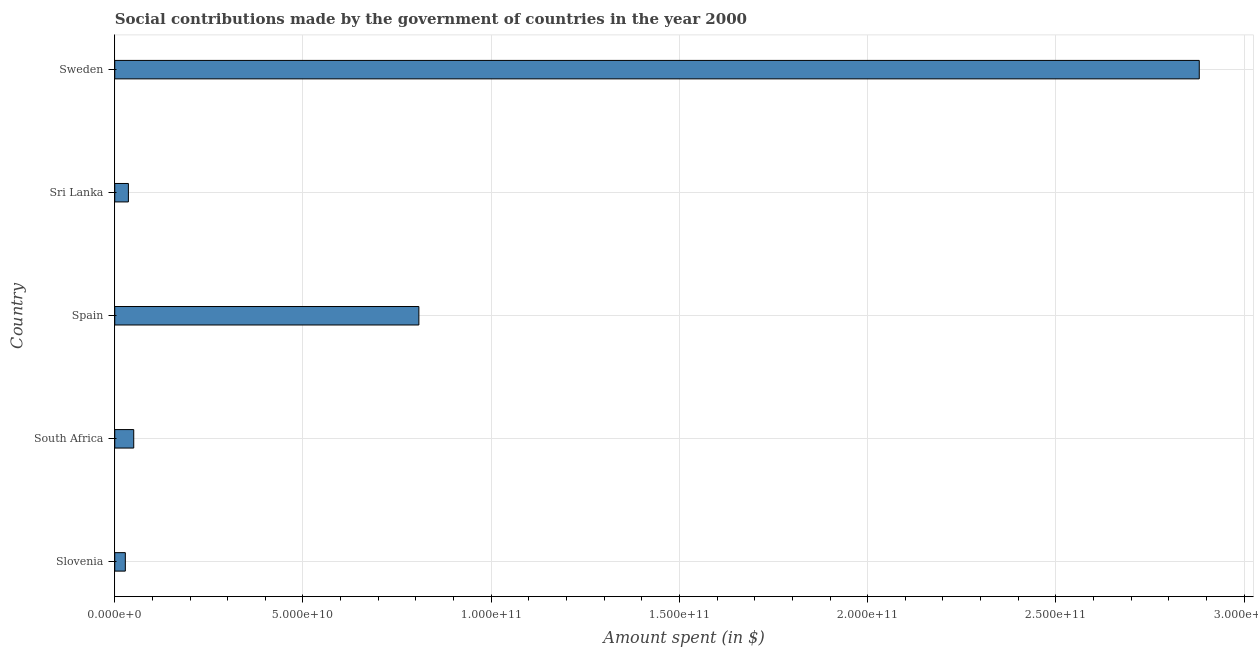Does the graph contain grids?
Offer a very short reply. Yes. What is the title of the graph?
Keep it short and to the point. Social contributions made by the government of countries in the year 2000. What is the label or title of the X-axis?
Offer a terse response. Amount spent (in $). What is the amount spent in making social contributions in Sweden?
Your answer should be very brief. 2.88e+11. Across all countries, what is the maximum amount spent in making social contributions?
Ensure brevity in your answer.  2.88e+11. Across all countries, what is the minimum amount spent in making social contributions?
Make the answer very short. 2.81e+09. In which country was the amount spent in making social contributions maximum?
Ensure brevity in your answer.  Sweden. In which country was the amount spent in making social contributions minimum?
Your response must be concise. Slovenia. What is the sum of the amount spent in making social contributions?
Your response must be concise. 3.80e+11. What is the difference between the amount spent in making social contributions in Spain and Sweden?
Provide a succinct answer. -2.07e+11. What is the average amount spent in making social contributions per country?
Give a very brief answer. 7.61e+1. What is the median amount spent in making social contributions?
Provide a short and direct response. 5.04e+09. What is the ratio of the amount spent in making social contributions in South Africa to that in Spain?
Ensure brevity in your answer.  0.06. Is the amount spent in making social contributions in Slovenia less than that in Sri Lanka?
Your answer should be compact. Yes. Is the difference between the amount spent in making social contributions in Slovenia and Spain greater than the difference between any two countries?
Your response must be concise. No. What is the difference between the highest and the second highest amount spent in making social contributions?
Offer a terse response. 2.07e+11. What is the difference between the highest and the lowest amount spent in making social contributions?
Provide a short and direct response. 2.85e+11. How many bars are there?
Offer a terse response. 5. Are all the bars in the graph horizontal?
Ensure brevity in your answer.  Yes. How many countries are there in the graph?
Offer a terse response. 5. Are the values on the major ticks of X-axis written in scientific E-notation?
Keep it short and to the point. Yes. What is the Amount spent (in $) of Slovenia?
Ensure brevity in your answer.  2.81e+09. What is the Amount spent (in $) in South Africa?
Provide a short and direct response. 5.04e+09. What is the Amount spent (in $) in Spain?
Your response must be concise. 8.08e+1. What is the Amount spent (in $) in Sri Lanka?
Offer a very short reply. 3.62e+09. What is the Amount spent (in $) of Sweden?
Make the answer very short. 2.88e+11. What is the difference between the Amount spent (in $) in Slovenia and South Africa?
Your response must be concise. -2.23e+09. What is the difference between the Amount spent (in $) in Slovenia and Spain?
Your answer should be very brief. -7.80e+1. What is the difference between the Amount spent (in $) in Slovenia and Sri Lanka?
Your answer should be very brief. -8.11e+08. What is the difference between the Amount spent (in $) in Slovenia and Sweden?
Keep it short and to the point. -2.85e+11. What is the difference between the Amount spent (in $) in South Africa and Spain?
Ensure brevity in your answer.  -7.57e+1. What is the difference between the Amount spent (in $) in South Africa and Sri Lanka?
Make the answer very short. 1.42e+09. What is the difference between the Amount spent (in $) in South Africa and Sweden?
Your answer should be compact. -2.83e+11. What is the difference between the Amount spent (in $) in Spain and Sri Lanka?
Your response must be concise. 7.72e+1. What is the difference between the Amount spent (in $) in Spain and Sweden?
Provide a short and direct response. -2.07e+11. What is the difference between the Amount spent (in $) in Sri Lanka and Sweden?
Provide a succinct answer. -2.84e+11. What is the ratio of the Amount spent (in $) in Slovenia to that in South Africa?
Your response must be concise. 0.56. What is the ratio of the Amount spent (in $) in Slovenia to that in Spain?
Make the answer very short. 0.04. What is the ratio of the Amount spent (in $) in Slovenia to that in Sri Lanka?
Give a very brief answer. 0.78. What is the ratio of the Amount spent (in $) in Slovenia to that in Sweden?
Provide a succinct answer. 0.01. What is the ratio of the Amount spent (in $) in South Africa to that in Spain?
Provide a short and direct response. 0.06. What is the ratio of the Amount spent (in $) in South Africa to that in Sri Lanka?
Your answer should be very brief. 1.39. What is the ratio of the Amount spent (in $) in South Africa to that in Sweden?
Ensure brevity in your answer.  0.02. What is the ratio of the Amount spent (in $) in Spain to that in Sri Lanka?
Your answer should be compact. 22.32. What is the ratio of the Amount spent (in $) in Spain to that in Sweden?
Provide a succinct answer. 0.28. What is the ratio of the Amount spent (in $) in Sri Lanka to that in Sweden?
Your response must be concise. 0.01. 